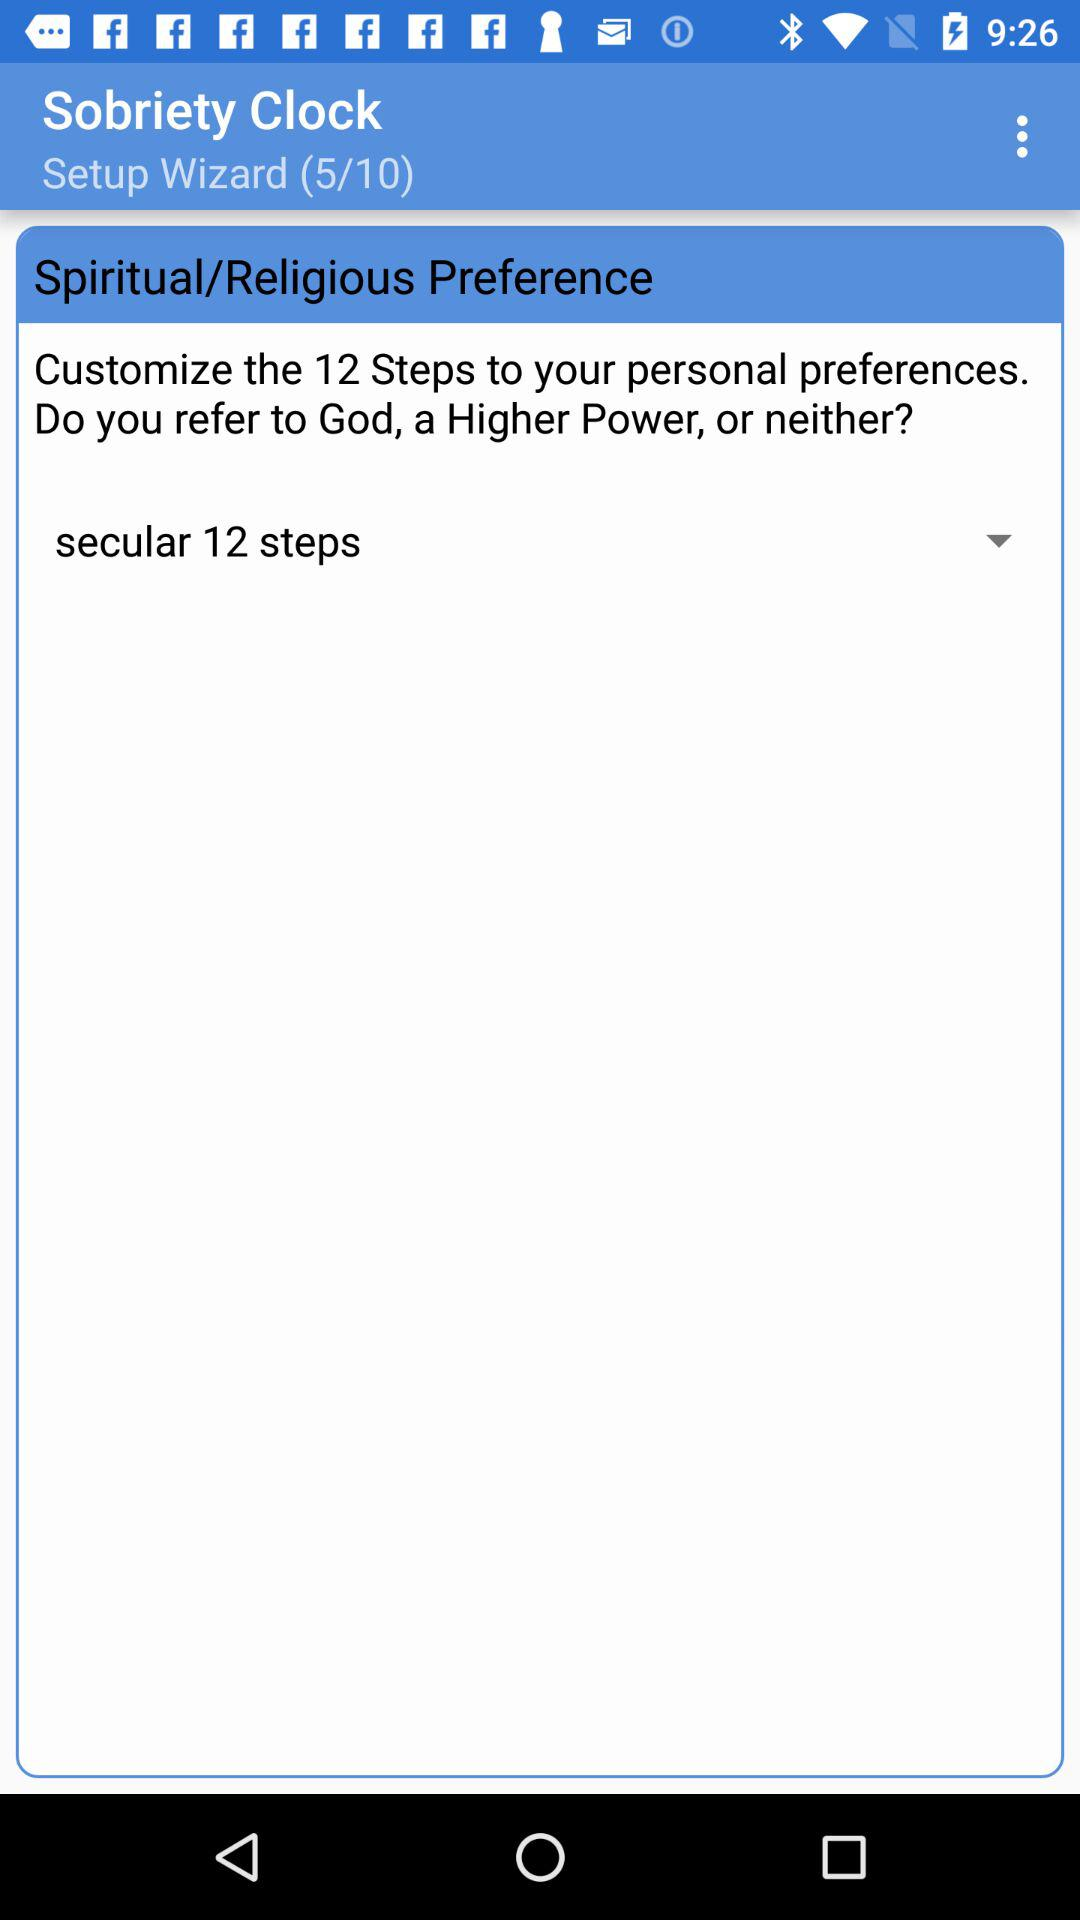At which setup wizard am I? You are at the fifth setup wizard. 